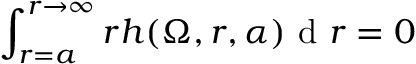Convert formula to latex. <formula><loc_0><loc_0><loc_500><loc_500>\int _ { r = a } ^ { r \to \infty } r h ( \Omega , r , \alpha ) d r = 0</formula> 